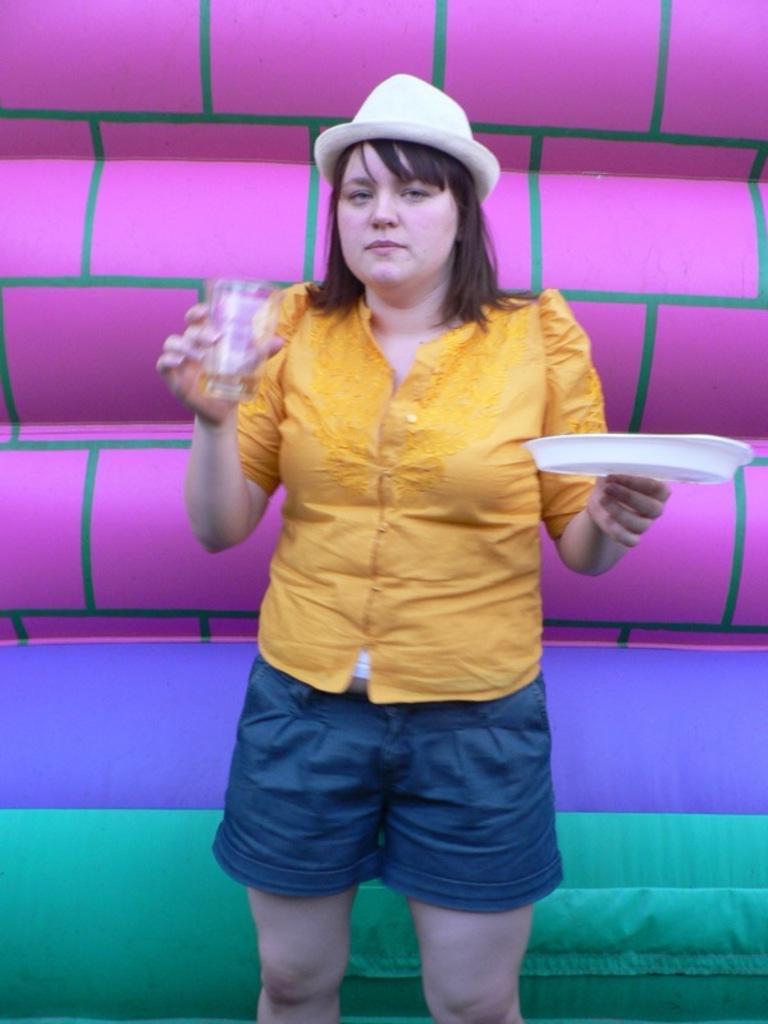Describe this image in one or two sentences. In this picture there is a girl standing and holding the plate and glass. At the back it looks like a balloon. 